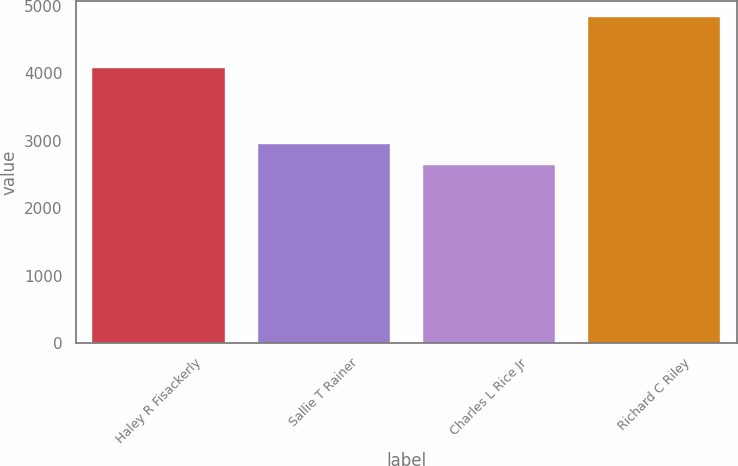Convert chart. <chart><loc_0><loc_0><loc_500><loc_500><bar_chart><fcel>Haley R Fisackerly<fcel>Sallie T Rainer<fcel>Charles L Rice Jr<fcel>Richard C Riley<nl><fcel>4082<fcel>2952<fcel>2637<fcel>4832<nl></chart> 